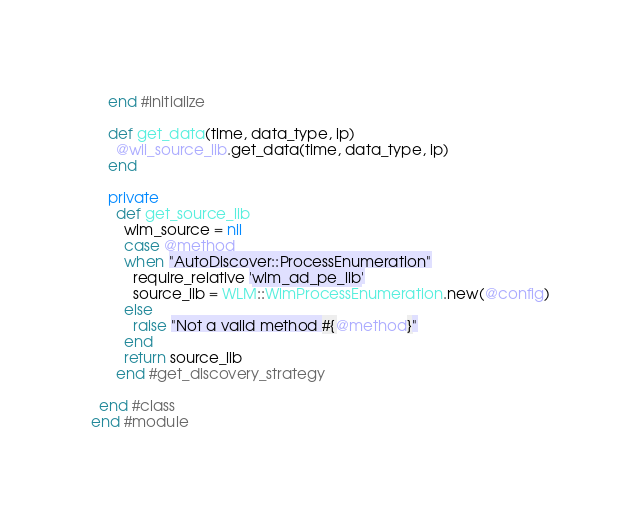<code> <loc_0><loc_0><loc_500><loc_500><_Ruby_>    end #initialize

    def get_data(time, data_type, ip)
      @wli_source_lib.get_data(time, data_type, ip)
    end

    private
      def get_source_lib
        wlm_source = nil
        case @method 
        when "AutoDiscover::ProcessEnumeration"
          require_relative 'wlm_ad_pe_lib'
          source_lib = WLM::WlmProcessEnumeration.new(@config)
        else 
          raise "Not a valid method #{@method}" 
        end 
        return source_lib
      end #get_discovery_strategy

  end #class
end #module
</code> 